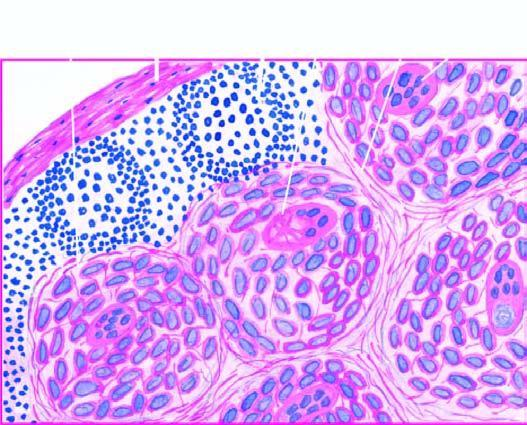s a giant cell with inclusions also seen in the photomicrograph?
Answer the question using a single word or phrase. Yes 